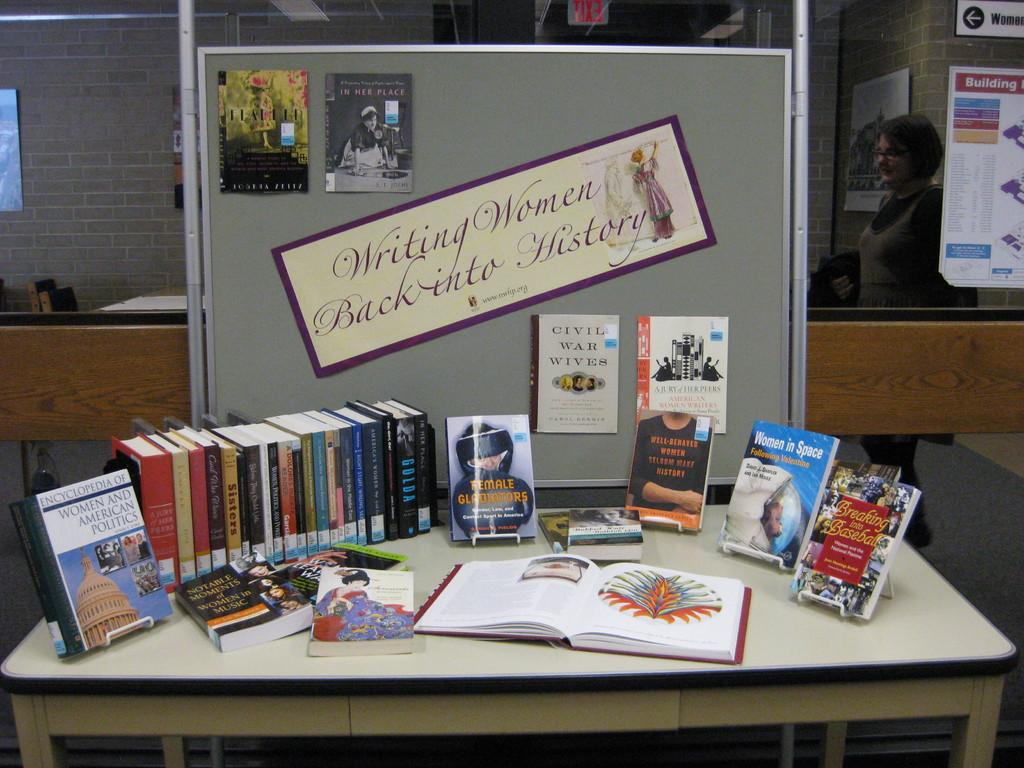<image>
Describe the image concisely. A library display titled Writing Women back into History 